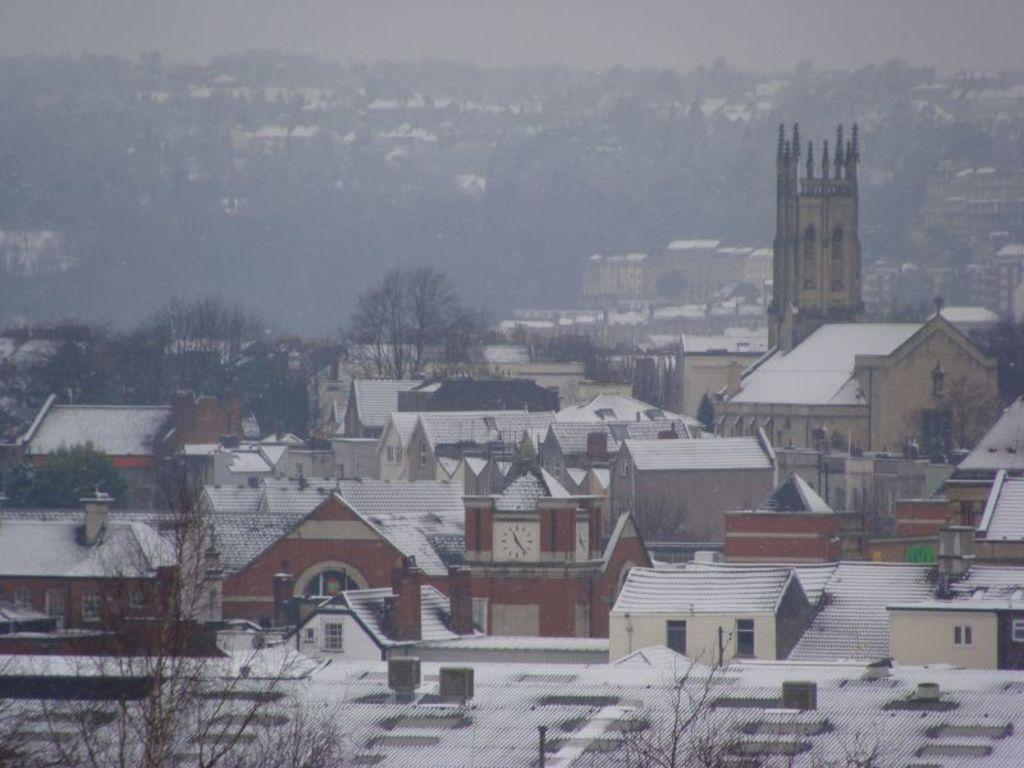What type of structures are present in the image? There are houses in the image. What is covering the houses in the image? There is snow on the houses. What type of vegetation can be seen in the image? There are trees in the image. What is visible in the background of the image? The sky is visible in the background of the image. What type of dinner is being served in the image? There is no dinner present in the image; it features houses with snow and trees. What sound can be heard coming from the houses in the image? There is no sound present in the image, as it is a still image. 